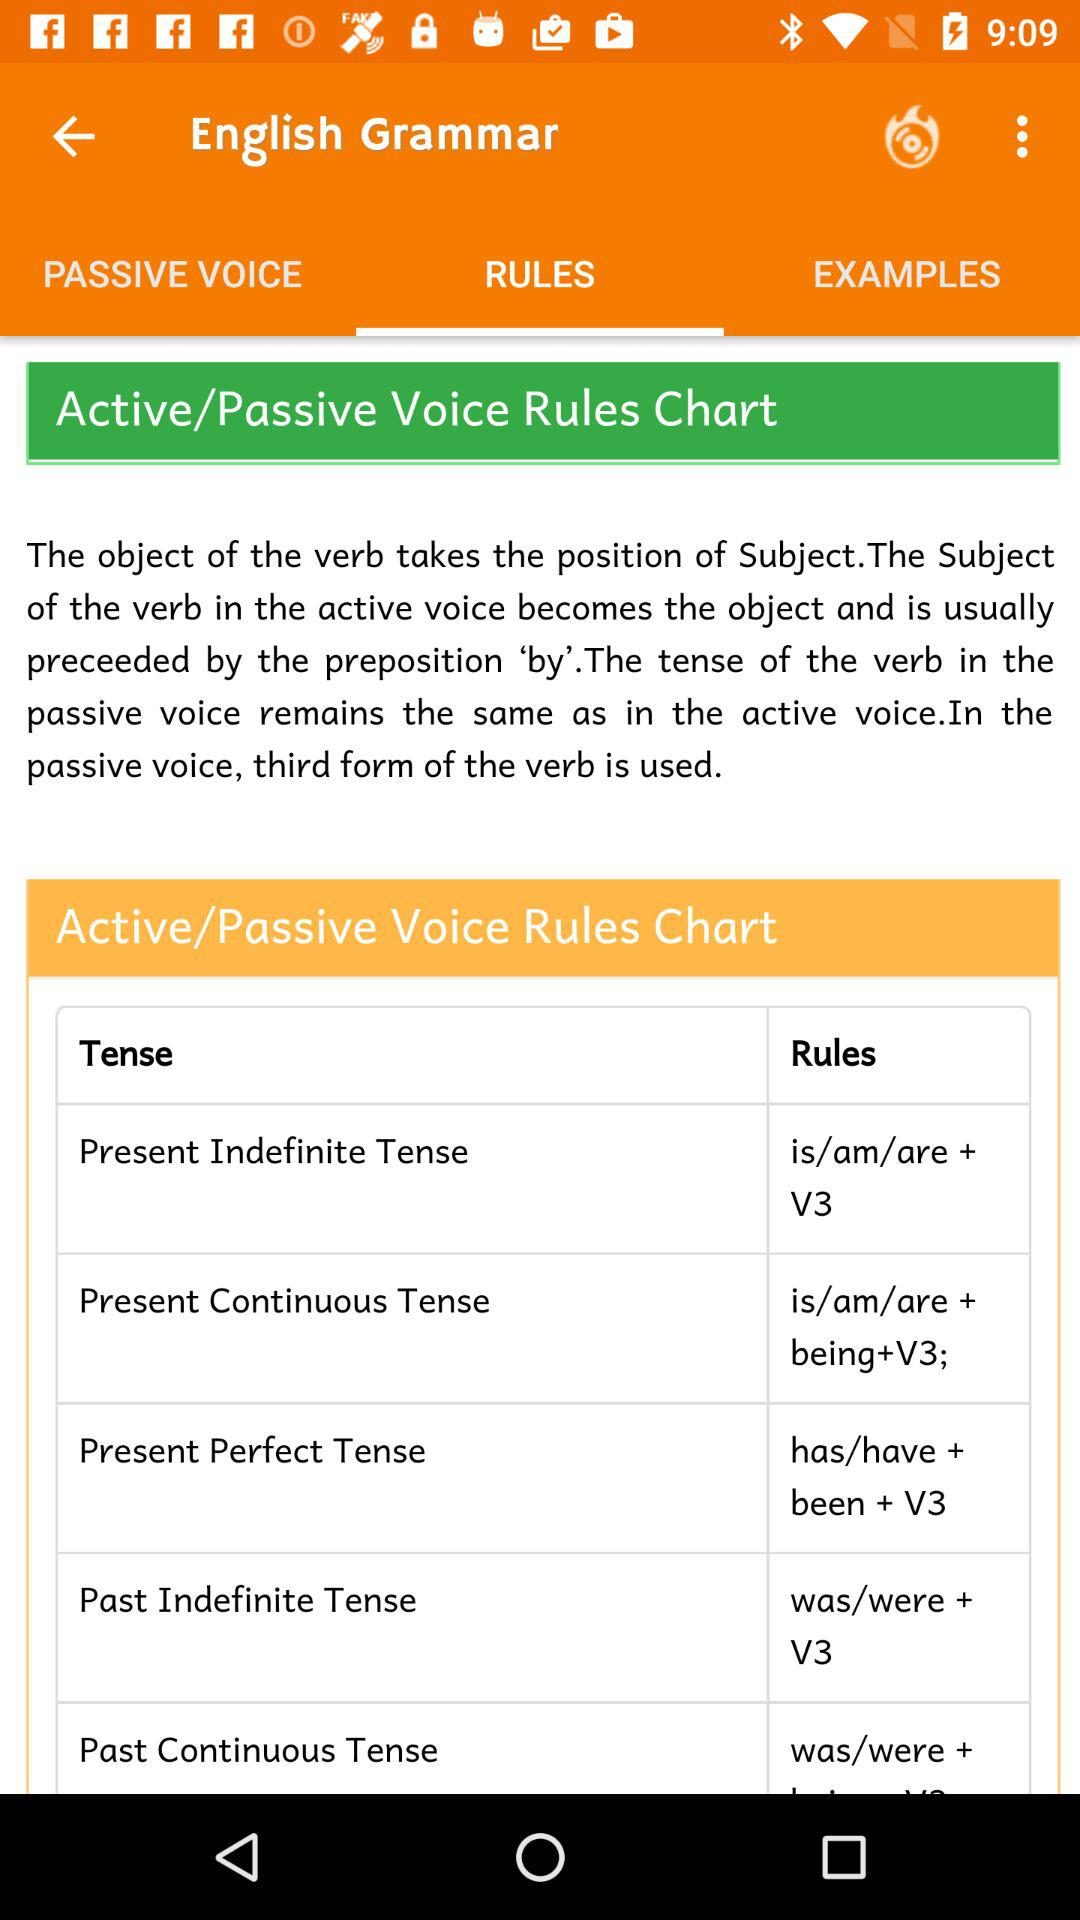How many rules are there for the present continuous tense?
Answer the question using a single word or phrase. 1 